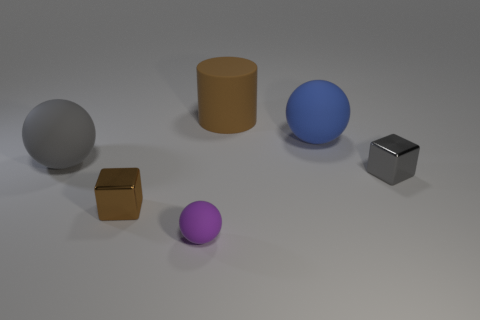There is a large matte object to the left of the cube left of the tiny gray shiny cube; what color is it?
Offer a very short reply. Gray. How big is the sphere to the left of the tiny metal object that is left of the tiny purple object?
Ensure brevity in your answer.  Large. There is a metal block that is the same color as the rubber cylinder; what size is it?
Make the answer very short. Small. How many other things are the same size as the blue ball?
Your response must be concise. 2. There is a small metal block behind the brown shiny object in front of the metallic object that is right of the brown cylinder; what is its color?
Make the answer very short. Gray. How many other things are the same shape as the large gray object?
Your response must be concise. 2. There is a gray object behind the small gray metallic thing; what shape is it?
Offer a terse response. Sphere. There is a gray thing left of the purple ball; are there any brown matte objects in front of it?
Your answer should be very brief. No. There is a large object that is in front of the brown matte thing and to the right of the purple rubber ball; what is its color?
Your answer should be very brief. Blue. There is a large thing that is left of the tiny metal object that is to the left of the gray cube; is there a matte object that is right of it?
Provide a succinct answer. Yes. 